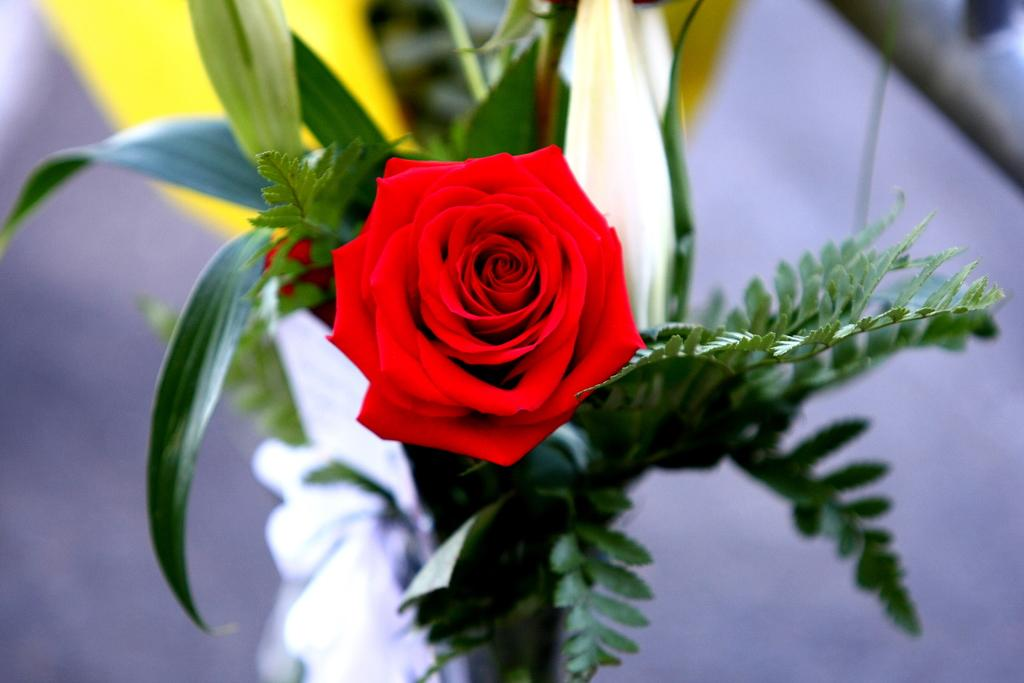What object can be seen in the image that is typically used for holding flowers? There is a flower vase in the image. What type of flower is in the vase? There is a red rose flower in the vase. What type of news can be seen on the cushion in the image? There is no cushion or news present in the image; it only features a flower vase with a red rose flower. 